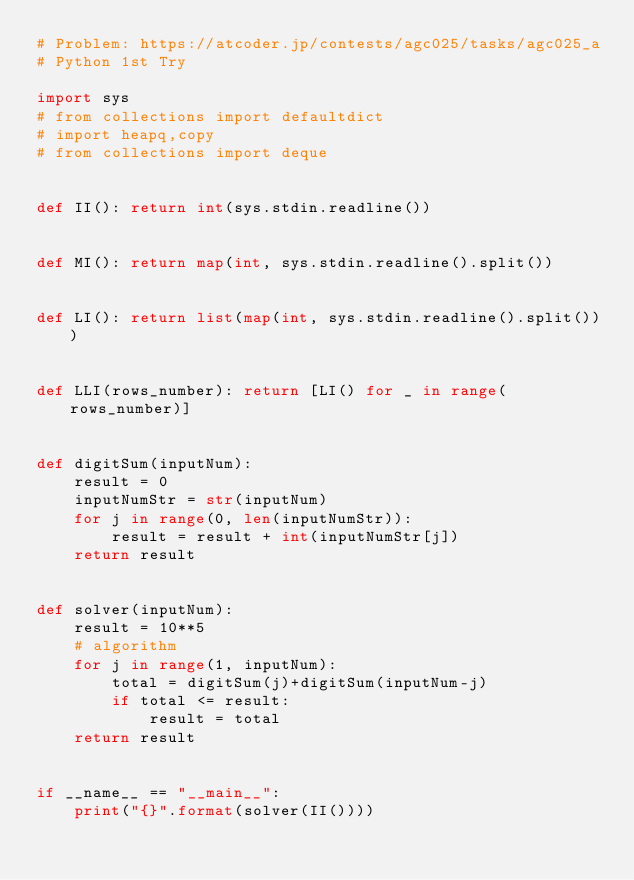Convert code to text. <code><loc_0><loc_0><loc_500><loc_500><_Python_># Problem: https://atcoder.jp/contests/agc025/tasks/agc025_a
# Python 1st Try

import sys
# from collections import defaultdict
# import heapq,copy
# from collections import deque


def II(): return int(sys.stdin.readline())


def MI(): return map(int, sys.stdin.readline().split())


def LI(): return list(map(int, sys.stdin.readline().split()))


def LLI(rows_number): return [LI() for _ in range(rows_number)]


def digitSum(inputNum):
    result = 0
    inputNumStr = str(inputNum)
    for j in range(0, len(inputNumStr)):
        result = result + int(inputNumStr[j])
    return result


def solver(inputNum):
    result = 10**5
    # algorithm
    for j in range(1, inputNum):
        total = digitSum(j)+digitSum(inputNum-j)
        if total <= result:
            result = total
    return result


if __name__ == "__main__":
    print("{}".format(solver(II())))
</code> 